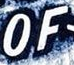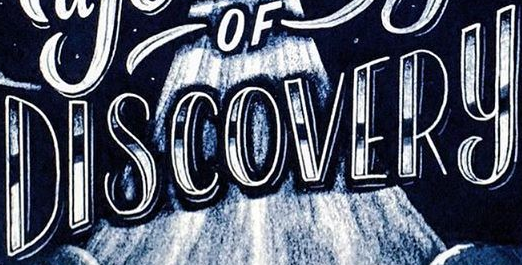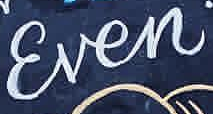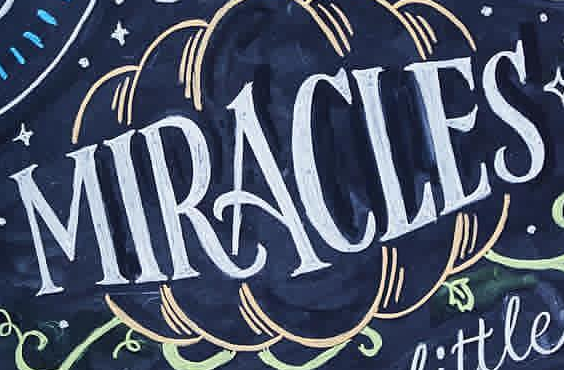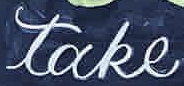What text is displayed in these images sequentially, separated by a semicolon? OF; DISCOVERY; Ɛven; MIRACLES; take 